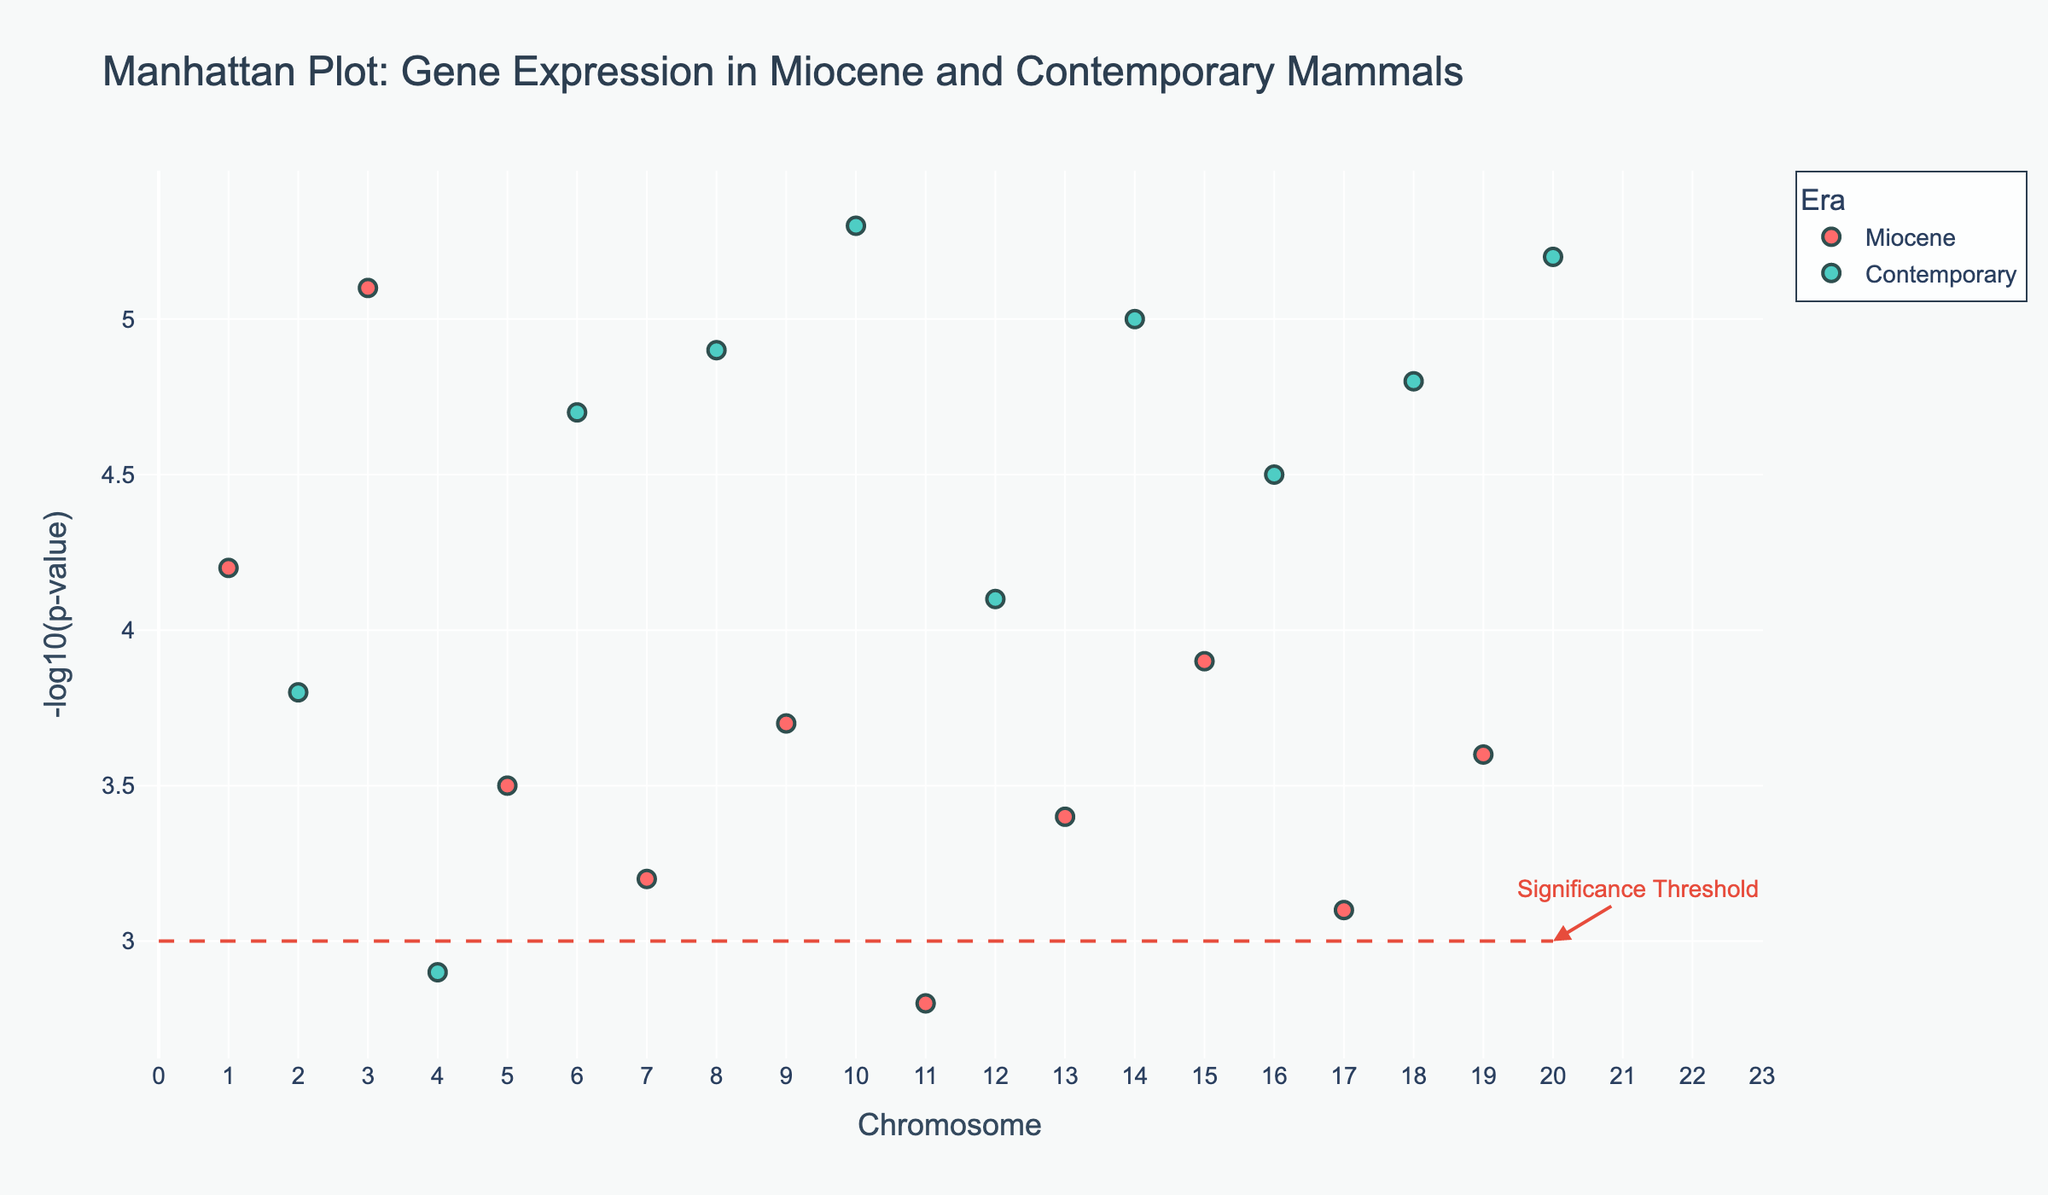What is the title of the Manhattan Plot? The title of the plot is usually found at the top of the figure. In this case, it is located centrally.
Answer: Manhattan Plot: Gene Expression in Miocene and Contemporary Mammals How many chromosomes are represented on the x-axis? The x-axis represents chromosomes, which can be identified by the tick marks and labels. The labels range from 1 to 20.
Answer: 20 What color is used to represent Miocene era data points? The colors of the data points differentiate the eras. Miocene era data points are shown in a particular color which stands out when compared to the Contemporary era data points.
Answer: Red Which chromosome has the highest -log10(p-value) in the plot? To find the highest -log10(p-value), look at the y-values and identify the data point with the maximum value. This data point is on chromosome 10.
Answer: Chromosome 10 How many genes are above the significance threshold? The significance threshold is marked by a horizontal dashed line at y=3. Count all data points that are above this line. There are several points from both Miocene and Contemporary eras above this threshold.
Answer: 18 Which era has more genes above the significance threshold? Compare the number of data points above the significant threshold for each era. Count the red (Miocene) and cyan (Contemporary) data points above the line.
Answer: Contemporary What gene has the second-highest -log10(p-value) and from which era does it come? Identify the second highest point on the y-axis and note the gene label and the corresponding era color. The second highest value is approximately y=5.2 with gene "FOXP2", from the Contemporary era.
Answer: FOXP2, Contemporary What is the range of -log10(p-value) for the Miocene era data points? Identify the minimum and maximum values for the red data points on the y-axis. The lowest -log10(p-value) for Miocene is 2.8 and the highest is 5.1.
Answer: 2.8 to 5.1 Which gene is located on Chromosome 5 and what is its -log10(p-value)? Look for the data point located at Chromosome 5 on the x-axis. Hover over or examine the figure to find the gene label and its corresponding -log10(p-value).
Answer: TYR, 3.5 